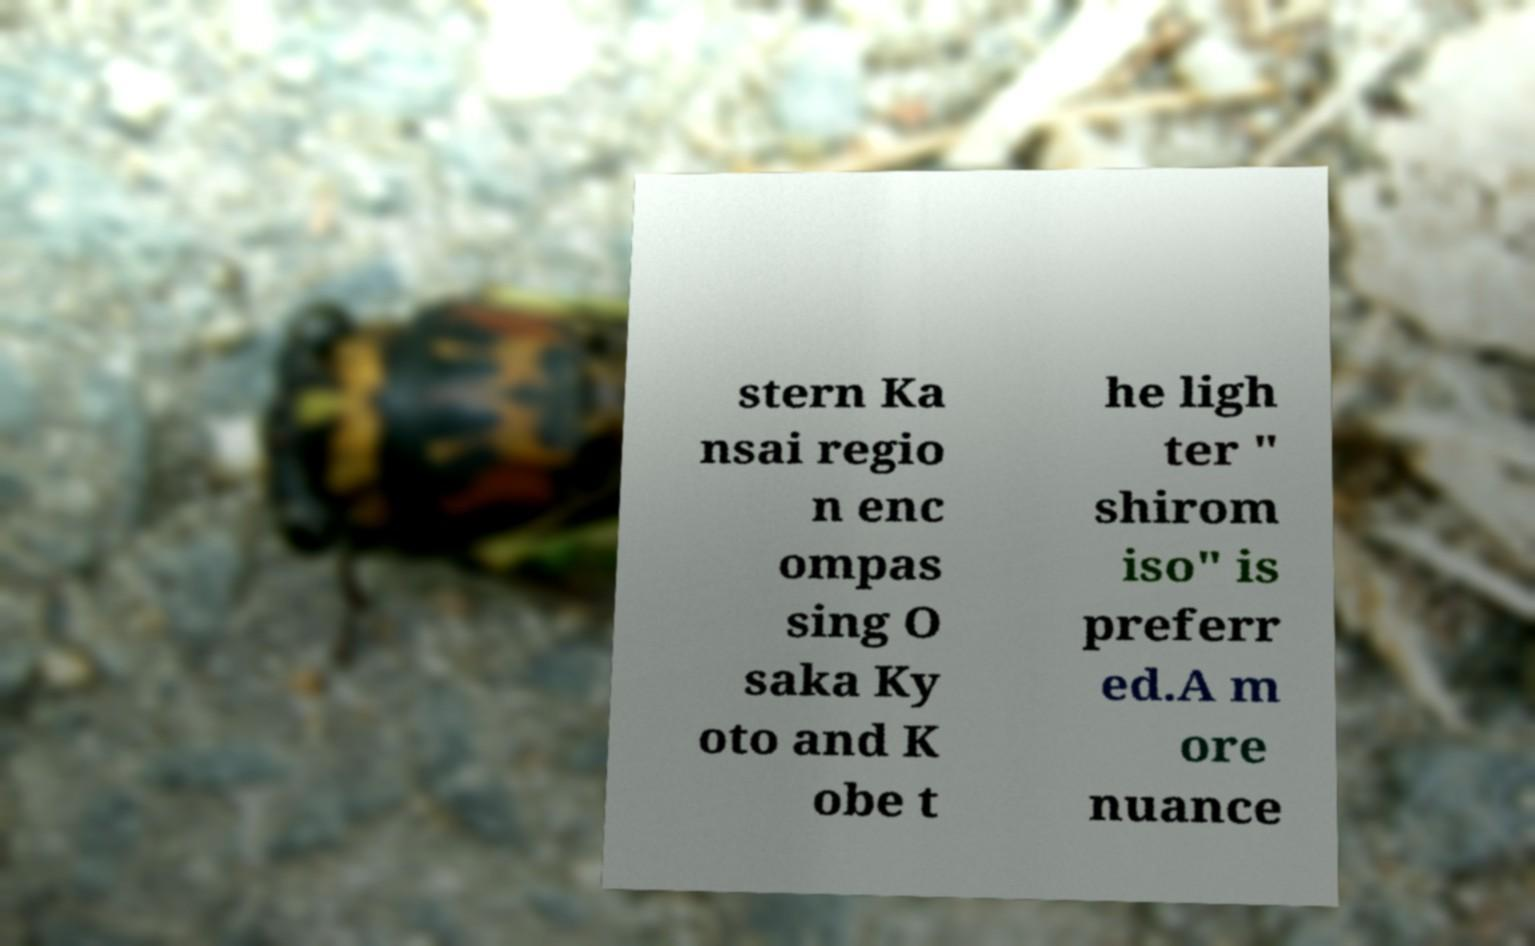Can you read and provide the text displayed in the image?This photo seems to have some interesting text. Can you extract and type it out for me? stern Ka nsai regio n enc ompas sing O saka Ky oto and K obe t he ligh ter " shirom iso" is preferr ed.A m ore nuance 